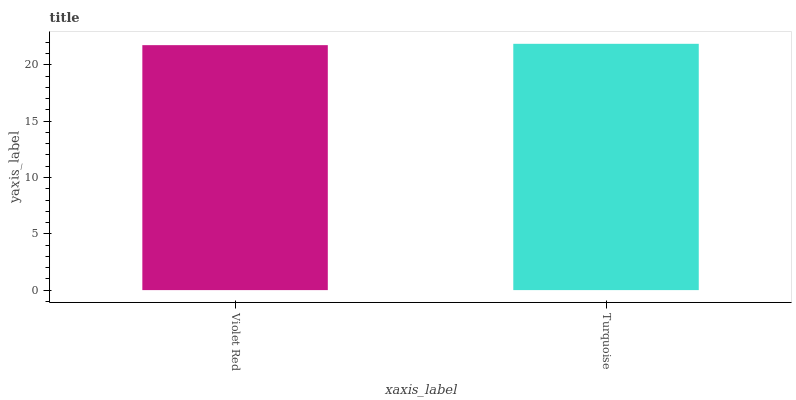Is Violet Red the minimum?
Answer yes or no. Yes. Is Turquoise the maximum?
Answer yes or no. Yes. Is Turquoise the minimum?
Answer yes or no. No. Is Turquoise greater than Violet Red?
Answer yes or no. Yes. Is Violet Red less than Turquoise?
Answer yes or no. Yes. Is Violet Red greater than Turquoise?
Answer yes or no. No. Is Turquoise less than Violet Red?
Answer yes or no. No. Is Turquoise the high median?
Answer yes or no. Yes. Is Violet Red the low median?
Answer yes or no. Yes. Is Violet Red the high median?
Answer yes or no. No. Is Turquoise the low median?
Answer yes or no. No. 